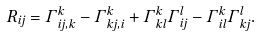Convert formula to latex. <formula><loc_0><loc_0><loc_500><loc_500>R _ { i j } = \Gamma ^ { k } _ { i j , k } - \Gamma ^ { k } _ { k j , i } + \Gamma ^ { k } _ { k l } \Gamma ^ { l } _ { i j } - \Gamma ^ { k } _ { i l } \Gamma ^ { l } _ { k j } .</formula> 